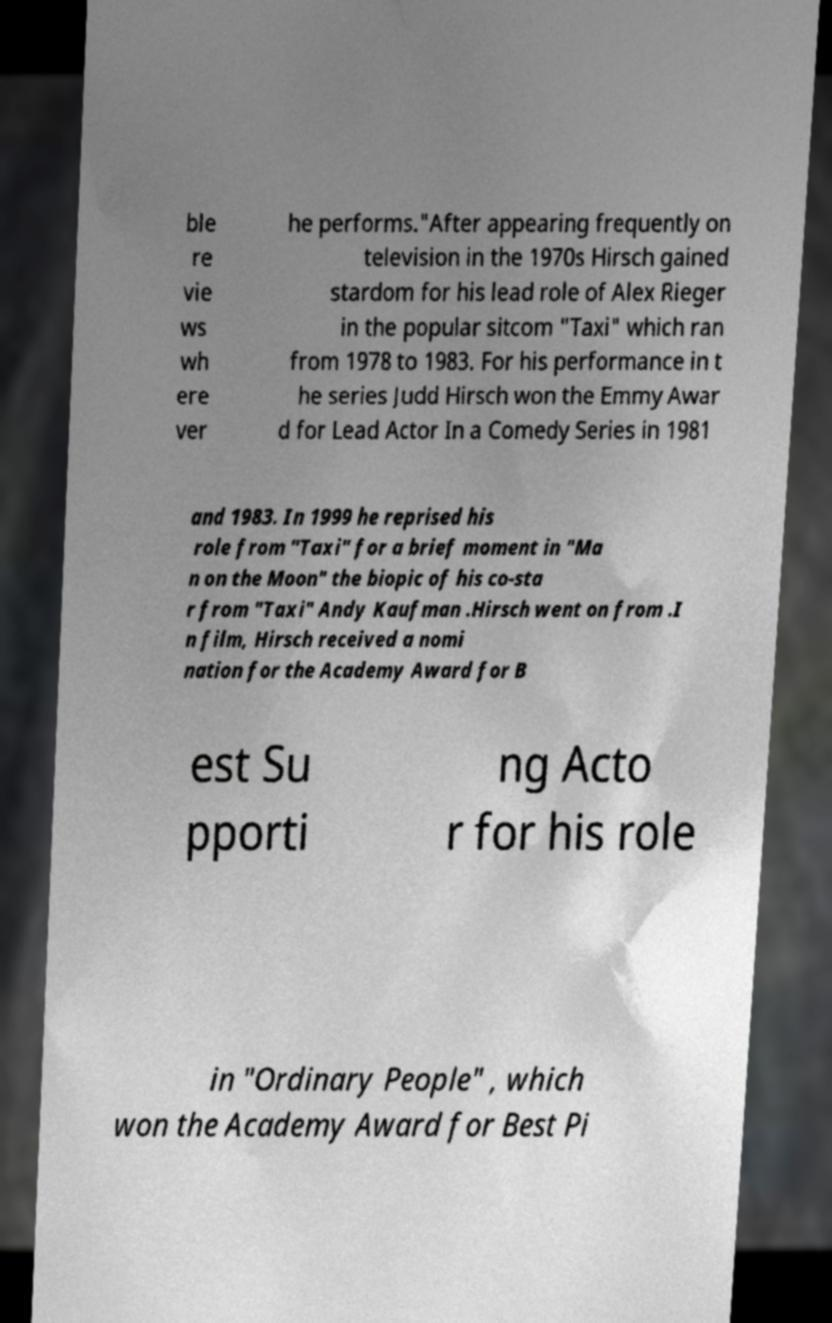Please identify and transcribe the text found in this image. ble re vie ws wh ere ver he performs."After appearing frequently on television in the 1970s Hirsch gained stardom for his lead role of Alex Rieger in the popular sitcom "Taxi" which ran from 1978 to 1983. For his performance in t he series Judd Hirsch won the Emmy Awar d for Lead Actor In a Comedy Series in 1981 and 1983. In 1999 he reprised his role from "Taxi" for a brief moment in "Ma n on the Moon" the biopic of his co-sta r from "Taxi" Andy Kaufman .Hirsch went on from .I n film, Hirsch received a nomi nation for the Academy Award for B est Su pporti ng Acto r for his role in "Ordinary People" , which won the Academy Award for Best Pi 